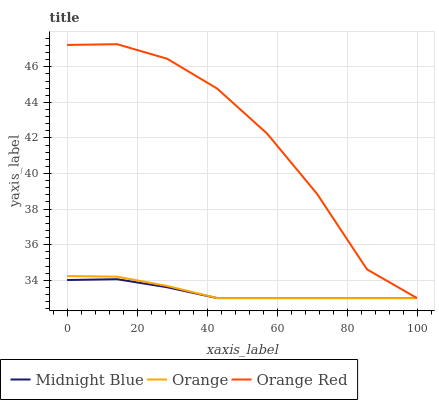Does Midnight Blue have the minimum area under the curve?
Answer yes or no. Yes. Does Orange Red have the maximum area under the curve?
Answer yes or no. Yes. Does Orange Red have the minimum area under the curve?
Answer yes or no. No. Does Midnight Blue have the maximum area under the curve?
Answer yes or no. No. Is Midnight Blue the smoothest?
Answer yes or no. Yes. Is Orange Red the roughest?
Answer yes or no. Yes. Is Orange Red the smoothest?
Answer yes or no. No. Is Midnight Blue the roughest?
Answer yes or no. No. Does Orange have the lowest value?
Answer yes or no. Yes. Does Orange Red have the highest value?
Answer yes or no. Yes. Does Midnight Blue have the highest value?
Answer yes or no. No. Does Midnight Blue intersect Orange?
Answer yes or no. Yes. Is Midnight Blue less than Orange?
Answer yes or no. No. Is Midnight Blue greater than Orange?
Answer yes or no. No. 